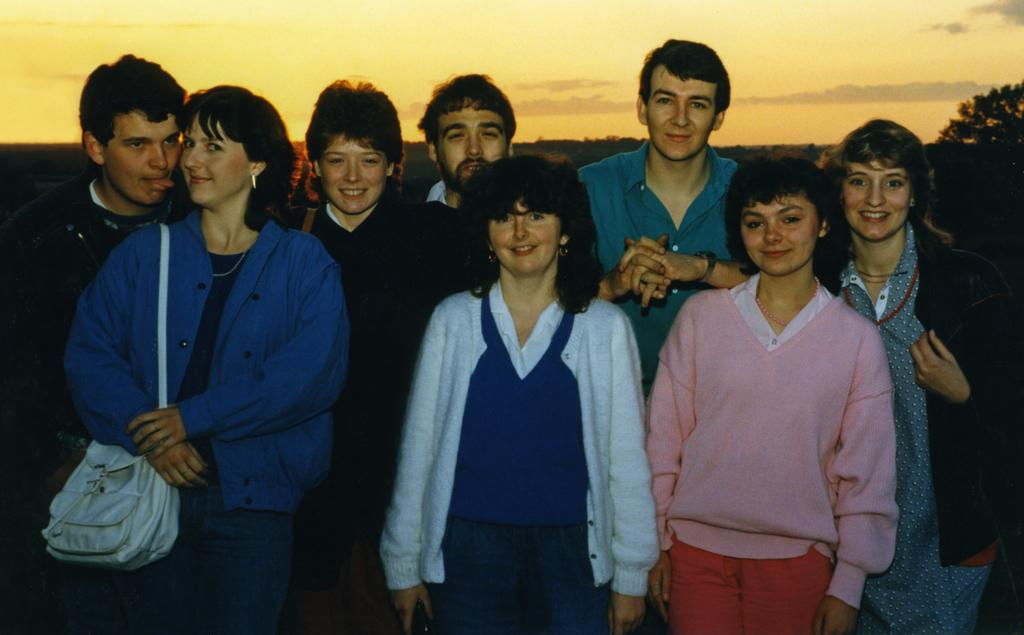How many people are in the image? There is a group of people in the image. What can be inferred about the time of day in the image? The image appears to depict a sunset. What type of produce is being harvested by the group of people in the image? There is no produce or harvesting activity depicted in the image; it only shows a group of people and a sunset. 